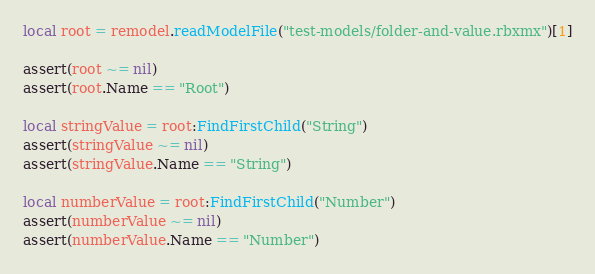<code> <loc_0><loc_0><loc_500><loc_500><_Lua_>local root = remodel.readModelFile("test-models/folder-and-value.rbxmx")[1]

assert(root ~= nil)
assert(root.Name == "Root")

local stringValue = root:FindFirstChild("String")
assert(stringValue ~= nil)
assert(stringValue.Name == "String")

local numberValue = root:FindFirstChild("Number")
assert(numberValue ~= nil)
assert(numberValue.Name == "Number")</code> 